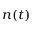<formula> <loc_0><loc_0><loc_500><loc_500>n ( t )</formula> 